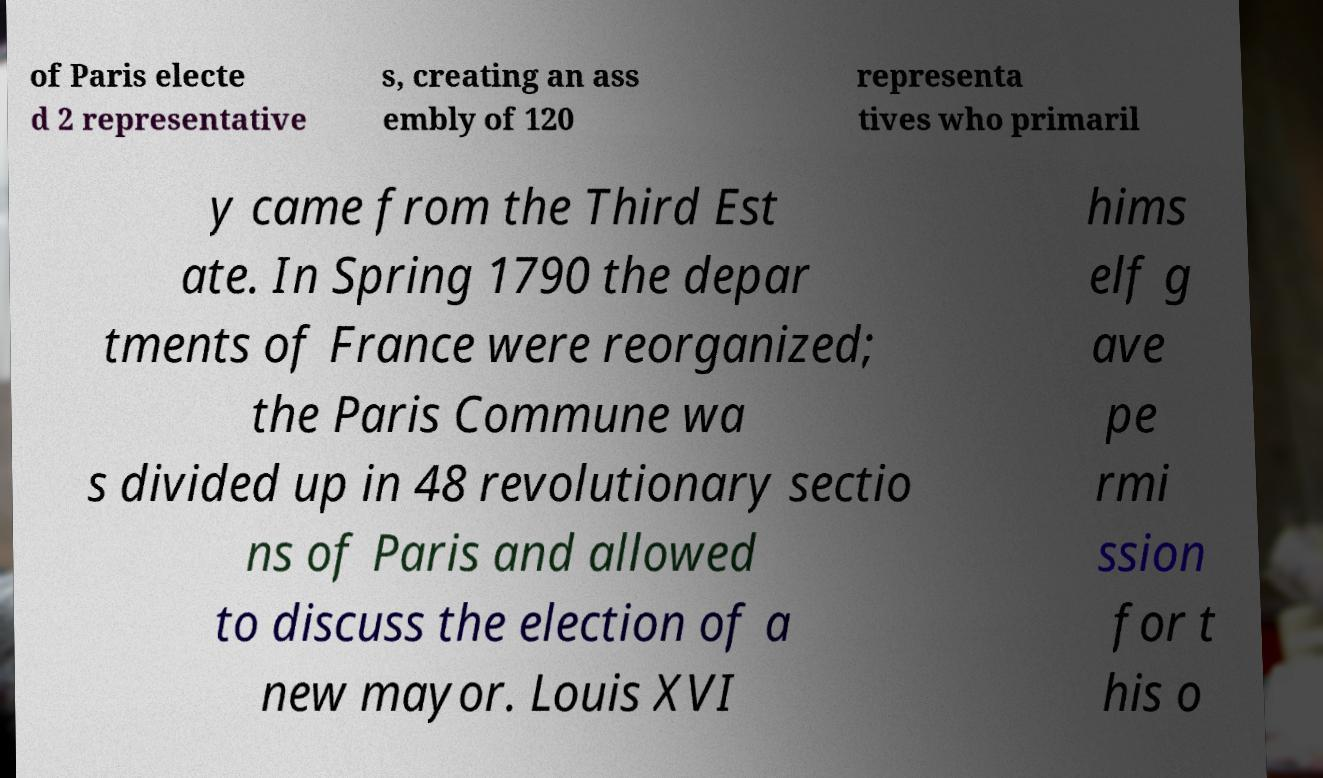There's text embedded in this image that I need extracted. Can you transcribe it verbatim? of Paris electe d 2 representative s, creating an ass embly of 120 representa tives who primaril y came from the Third Est ate. In Spring 1790 the depar tments of France were reorganized; the Paris Commune wa s divided up in 48 revolutionary sectio ns of Paris and allowed to discuss the election of a new mayor. Louis XVI hims elf g ave pe rmi ssion for t his o 